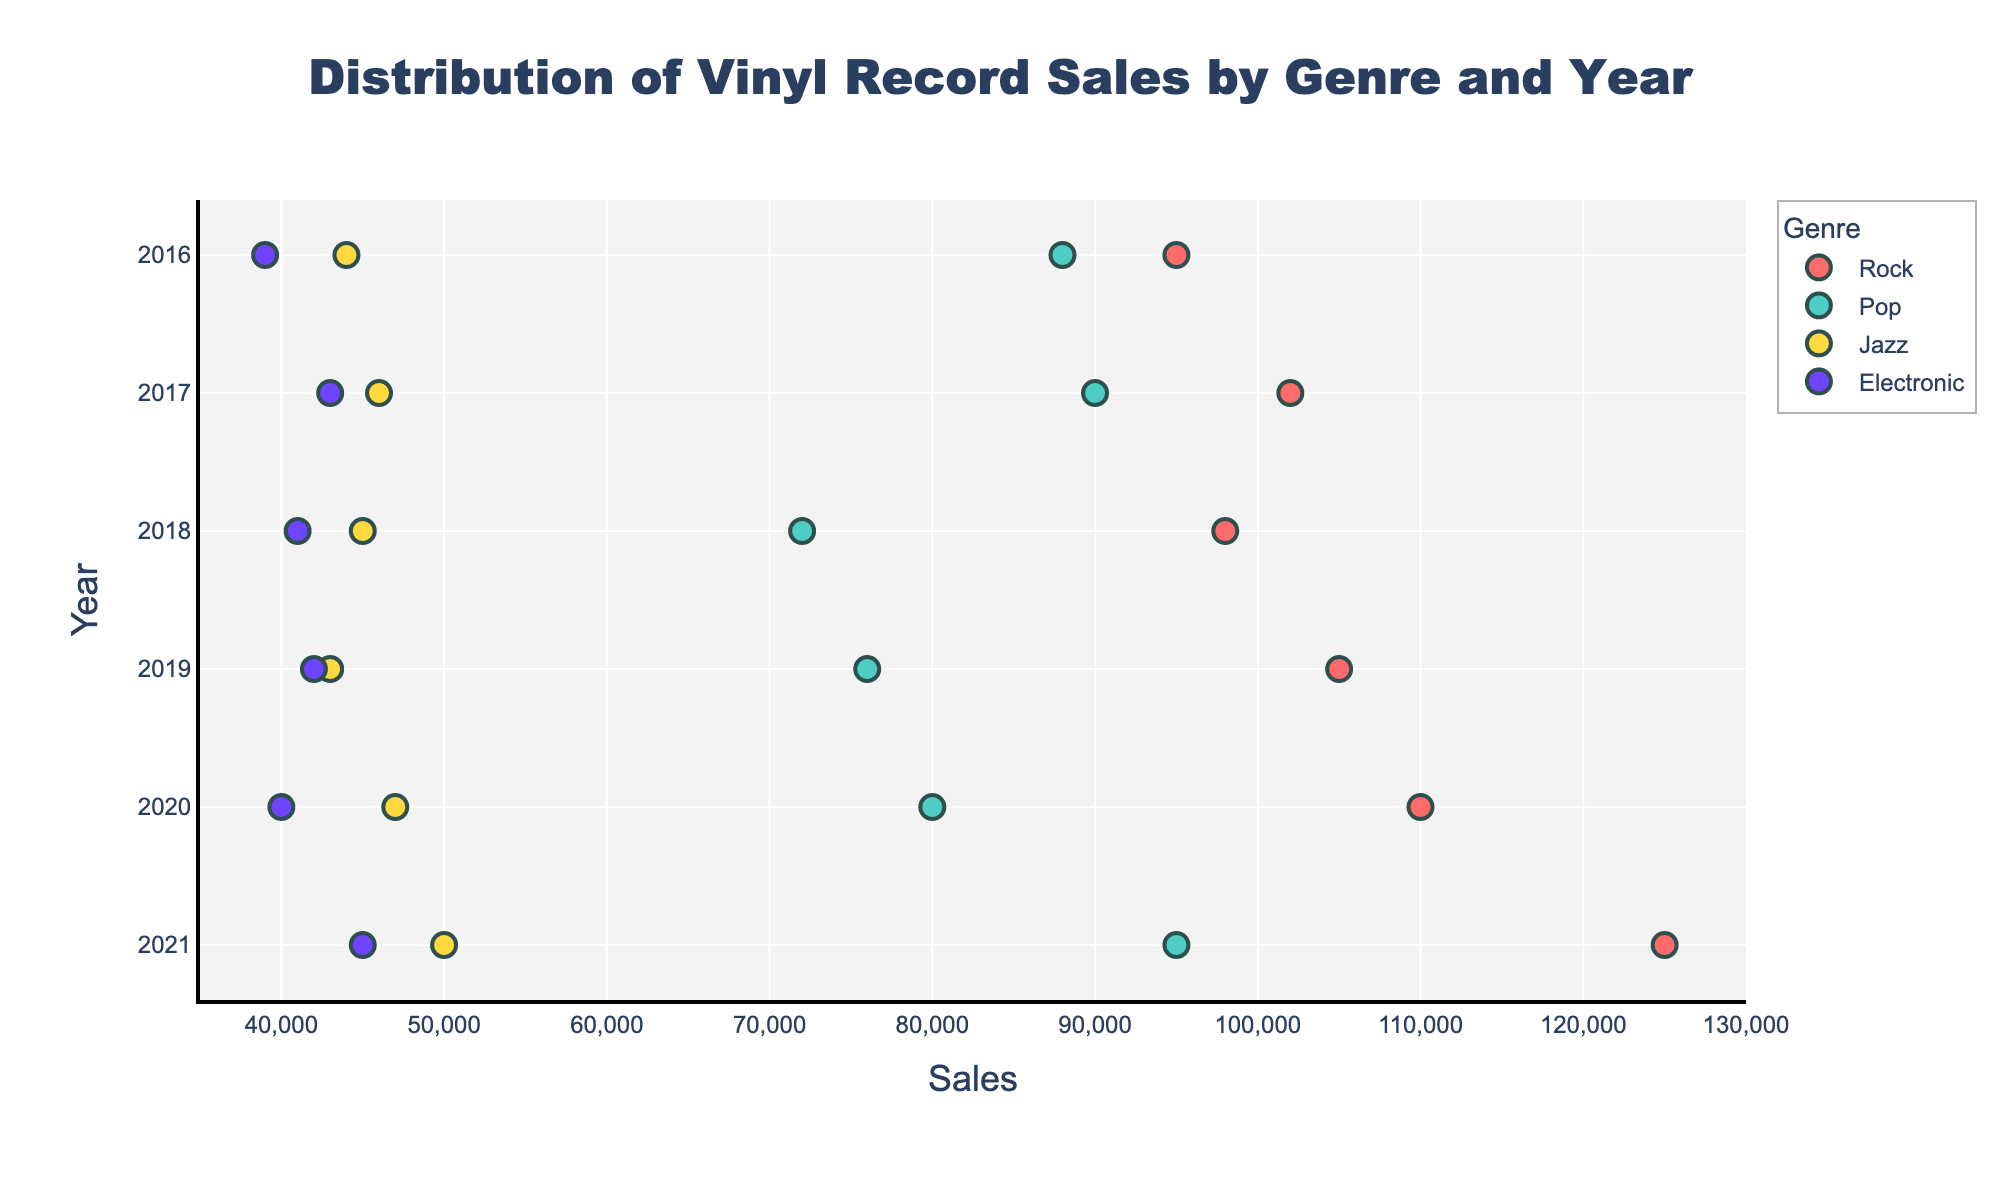Which genre has the highest vinyl sales in 2021? Looking at the data points for the year 2021, the Rock genre has the highest sales with Fleetwood Mac selling 125,000 records.
Answer: Rock What are the total vinyl sales for Pop genre in 2020? The Pop genre in 2020 lists Billie Eilish with sales of 80,000. When summed up, it remains 80,000 as there's only one data point.
Answer: 80,000 Which year had the lowest sales for Electronic genre? By checking the sales figures for the Electronic genre across all years, 2016 has the lowest sales with Skrillex selling 39,000 records.
Answer: 2016 How much more did Pink Floyd sell in 2018 compared to Deadmau5? In 2018, Pink Floyd sold 98,000 records while Deadmau5 sold 41,000. The difference is 98,000 - 41,000 = 57,000.
Answer: 57,000 What is the average sales for Jazz genre between 2017 and 2019? For the Jazz genre, 2017 had 46,000 (Thelonious Monk), 2018 had 45,000 (Duke Ellington), and 2019 had 43,000 (Herbie Hancock). The average is (46,000 + 45,000 + 43,000) / 3 = 44,667.
Answer: 44,667 Which genre had the most consistent sales over the years? By observing the scatter plot, the Electronic genre shows the least variation in sales figures (ranging between 39,000 and 45,000), indicating the most consistency.
Answer: Electronic Did Adele or Ed Sheeran have higher vinyl sales in their respective years? Comparing Adele's sales in 2016 (88,000) and Ed Sheeran's in 2017 (90,000), Ed Sheeran had higher sales.
Answer: Ed Sheeran What is the range of sales for the Rock genre in 2020? In 2020, The Beatles sold 110,000 records. As there is a single data point, the range is essentially from 110,000 to 110,000.
Answer: 0 Which Pop artist had the second-highest sales in 2021? Observing the 2021 data for Pop genre, Taylor Swift had the highest sales (95,000). There is only one entry for Pop in 2021, so there isn't a second-highest.
Answer: N/A What is the sales difference between The Beatles in 2020 and David Bowie in 2016? The Beatles sold 110,000 records in 2020, while David Bowie sold 95,000 in 2016. The difference is 110,000 - 95,000 = 15,000.
Answer: 15,000 